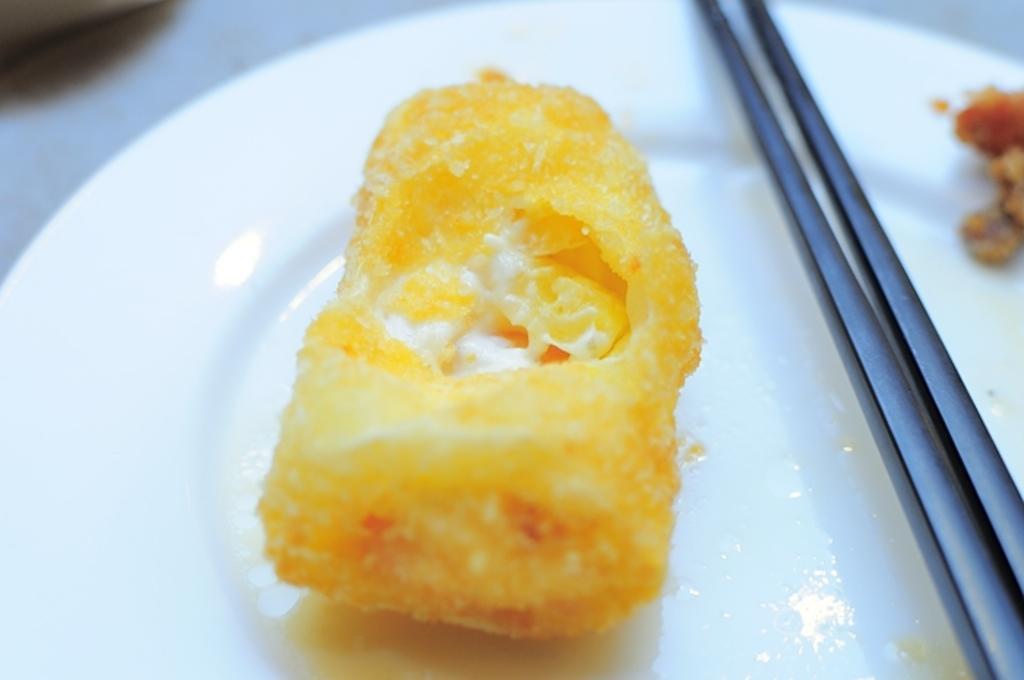In one or two sentences, can you explain what this image depicts? In this image, I can see a plate, which contains food item on it. I think these are the chopsticks. 